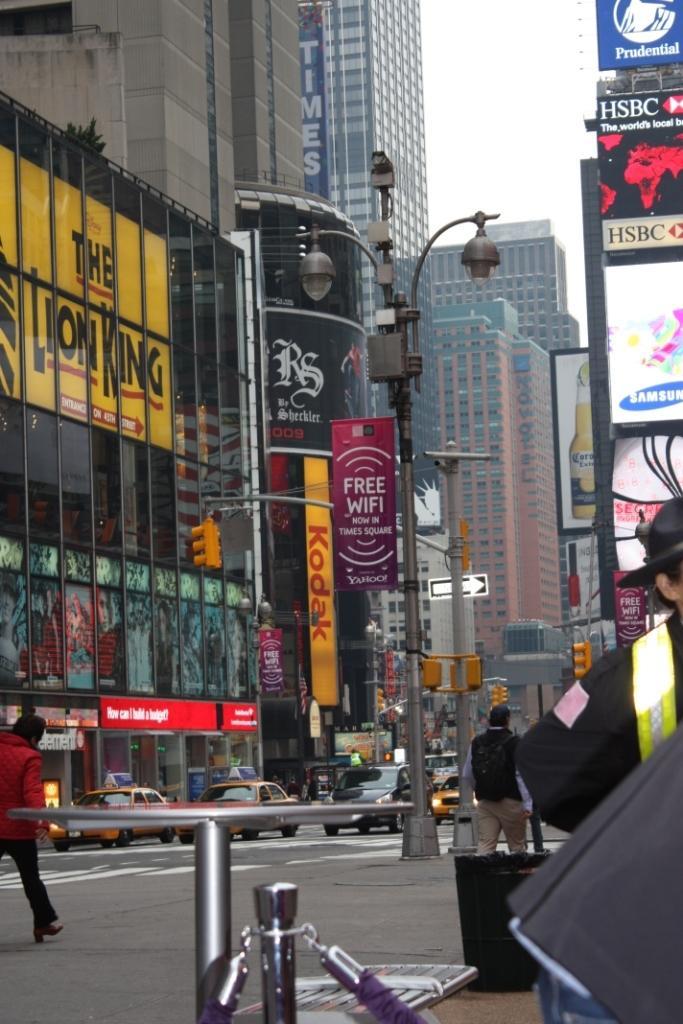In one or two sentences, can you explain what this image depicts? In this picture, we can see a few people, a few buildings with windows, posters, and w e can see poles, lights, sign boards, posters, and w e can see the sky. 